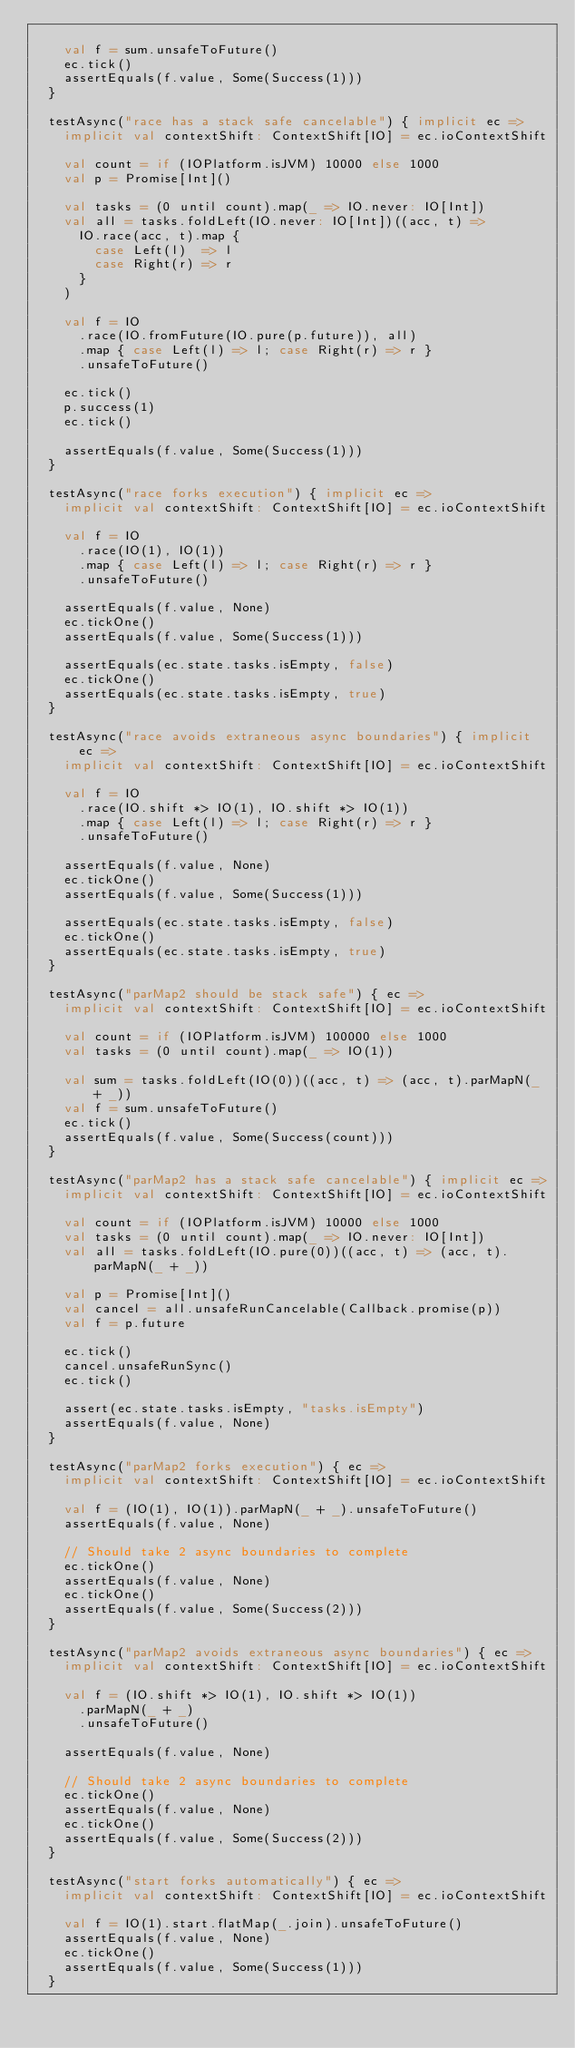Convert code to text. <code><loc_0><loc_0><loc_500><loc_500><_Scala_>
    val f = sum.unsafeToFuture()
    ec.tick()
    assertEquals(f.value, Some(Success(1)))
  }

  testAsync("race has a stack safe cancelable") { implicit ec =>
    implicit val contextShift: ContextShift[IO] = ec.ioContextShift

    val count = if (IOPlatform.isJVM) 10000 else 1000
    val p = Promise[Int]()

    val tasks = (0 until count).map(_ => IO.never: IO[Int])
    val all = tasks.foldLeft(IO.never: IO[Int])((acc, t) =>
      IO.race(acc, t).map {
        case Left(l)  => l
        case Right(r) => r
      }
    )

    val f = IO
      .race(IO.fromFuture(IO.pure(p.future)), all)
      .map { case Left(l) => l; case Right(r) => r }
      .unsafeToFuture()

    ec.tick()
    p.success(1)
    ec.tick()

    assertEquals(f.value, Some(Success(1)))
  }

  testAsync("race forks execution") { implicit ec =>
    implicit val contextShift: ContextShift[IO] = ec.ioContextShift

    val f = IO
      .race(IO(1), IO(1))
      .map { case Left(l) => l; case Right(r) => r }
      .unsafeToFuture()

    assertEquals(f.value, None)
    ec.tickOne()
    assertEquals(f.value, Some(Success(1)))

    assertEquals(ec.state.tasks.isEmpty, false)
    ec.tickOne()
    assertEquals(ec.state.tasks.isEmpty, true)
  }

  testAsync("race avoids extraneous async boundaries") { implicit ec =>
    implicit val contextShift: ContextShift[IO] = ec.ioContextShift

    val f = IO
      .race(IO.shift *> IO(1), IO.shift *> IO(1))
      .map { case Left(l) => l; case Right(r) => r }
      .unsafeToFuture()

    assertEquals(f.value, None)
    ec.tickOne()
    assertEquals(f.value, Some(Success(1)))

    assertEquals(ec.state.tasks.isEmpty, false)
    ec.tickOne()
    assertEquals(ec.state.tasks.isEmpty, true)
  }

  testAsync("parMap2 should be stack safe") { ec =>
    implicit val contextShift: ContextShift[IO] = ec.ioContextShift

    val count = if (IOPlatform.isJVM) 100000 else 1000
    val tasks = (0 until count).map(_ => IO(1))

    val sum = tasks.foldLeft(IO(0))((acc, t) => (acc, t).parMapN(_ + _))
    val f = sum.unsafeToFuture()
    ec.tick()
    assertEquals(f.value, Some(Success(count)))
  }

  testAsync("parMap2 has a stack safe cancelable") { implicit ec =>
    implicit val contextShift: ContextShift[IO] = ec.ioContextShift

    val count = if (IOPlatform.isJVM) 10000 else 1000
    val tasks = (0 until count).map(_ => IO.never: IO[Int])
    val all = tasks.foldLeft(IO.pure(0))((acc, t) => (acc, t).parMapN(_ + _))

    val p = Promise[Int]()
    val cancel = all.unsafeRunCancelable(Callback.promise(p))
    val f = p.future

    ec.tick()
    cancel.unsafeRunSync()
    ec.tick()

    assert(ec.state.tasks.isEmpty, "tasks.isEmpty")
    assertEquals(f.value, None)
  }

  testAsync("parMap2 forks execution") { ec =>
    implicit val contextShift: ContextShift[IO] = ec.ioContextShift

    val f = (IO(1), IO(1)).parMapN(_ + _).unsafeToFuture()
    assertEquals(f.value, None)

    // Should take 2 async boundaries to complete
    ec.tickOne()
    assertEquals(f.value, None)
    ec.tickOne()
    assertEquals(f.value, Some(Success(2)))
  }

  testAsync("parMap2 avoids extraneous async boundaries") { ec =>
    implicit val contextShift: ContextShift[IO] = ec.ioContextShift

    val f = (IO.shift *> IO(1), IO.shift *> IO(1))
      .parMapN(_ + _)
      .unsafeToFuture()

    assertEquals(f.value, None)

    // Should take 2 async boundaries to complete
    ec.tickOne()
    assertEquals(f.value, None)
    ec.tickOne()
    assertEquals(f.value, Some(Success(2)))
  }

  testAsync("start forks automatically") { ec =>
    implicit val contextShift: ContextShift[IO] = ec.ioContextShift

    val f = IO(1).start.flatMap(_.join).unsafeToFuture()
    assertEquals(f.value, None)
    ec.tickOne()
    assertEquals(f.value, Some(Success(1)))
  }
</code> 